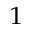Convert formula to latex. <formula><loc_0><loc_0><loc_500><loc_500>^ { 1 }</formula> 